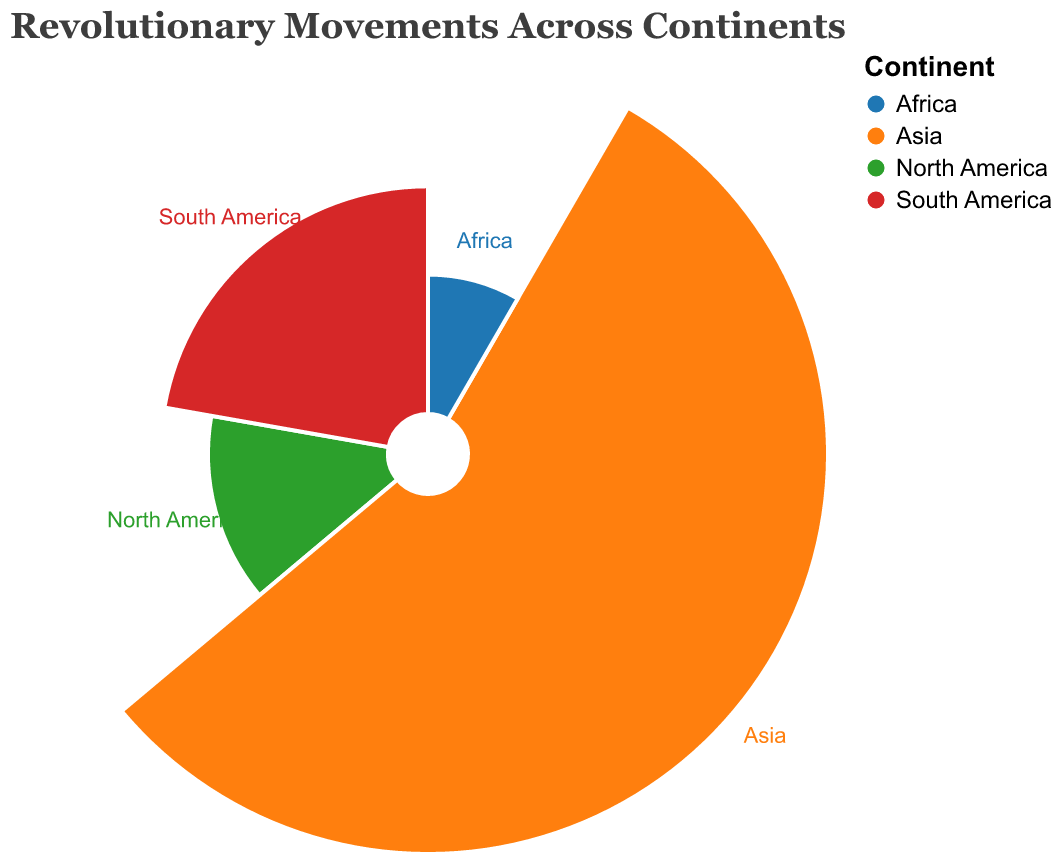What is the title of the chart? The title of the chart is displayed at the top in a larger font size.
Answer: Revolutionary Movements Across Continents Which continent had the revolutionary movement with the highest number of participants? Look at the segments and radial lines to identify which segment extends the farthest from the center. The data label will show the highest number of participants.
Answer: Asia Which revolutionary movement took place in Africa? By analyzing the segments and associated text labels, the segment colored for Africa shows a label for the specific revolutionary movement.
Answer: Algerian War of Independence How many participants were there in the American Revolution? The tooltip or the data label for the North America segment shows the exact number of participants.
Answer: 250,000 Compare the number of participants in the Indian Independence Movement and Algerian War of Independence. Which had more participants, and by how much? Look at the segments for Asia and Africa. Find the data labels, then subtract the smaller value from the larger value.
Answer: Indian Independence Movement had 850,000 more participants What major outcome resulted from the Latin American Wars of Independence? By examining the tooltip data or the text labels associated with the South America segment, you can find the major outcome description.
Answer: Independence of several Latin American countries What is the average number of participants for all revolutionary movements shown in the chart? Sum up the participants for all movements and divide by the number of movements: (250 + 400 + 1000 + 150)/4 = 1800/4
Answer: 450,000 Which continent had a revolutionary movement that led to the formation of a new country? Check the text labels in the tooltip or associated with each segment to find the description that mentions the formation of a new country.
Answer: North America What was the time range of the Indian Independence Movement? By examining the tooltip or the data label for the Asia segment, find the specific years mentioned for the movement.
Answer: 1857-1947 In which revolutionary movement did 400,000 participants take part? By checking the radial distances and associated text labels, identify the movement with the matching number of participants.
Answer: Latin American Wars of Independence 